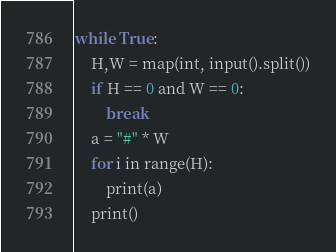Convert code to text. <code><loc_0><loc_0><loc_500><loc_500><_Python_>while True:
    H,W = map(int, input().split())
    if H == 0 and W == 0:
        break
    a = "#" * W
    for i in range(H):
        print(a)
    print()</code> 